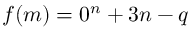Convert formula to latex. <formula><loc_0><loc_0><loc_500><loc_500>f ( m ) = 0 ^ { n } + 3 n - q</formula> 